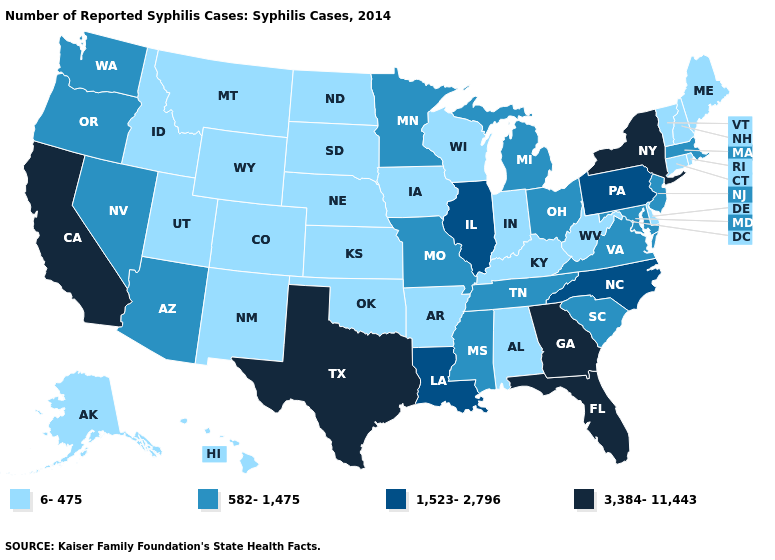Name the states that have a value in the range 1,523-2,796?
Answer briefly. Illinois, Louisiana, North Carolina, Pennsylvania. What is the highest value in states that border New Mexico?
Write a very short answer. 3,384-11,443. What is the value of Missouri?
Short answer required. 582-1,475. How many symbols are there in the legend?
Write a very short answer. 4. What is the value of Pennsylvania?
Short answer required. 1,523-2,796. Name the states that have a value in the range 1,523-2,796?
Short answer required. Illinois, Louisiana, North Carolina, Pennsylvania. Name the states that have a value in the range 6-475?
Short answer required. Alabama, Alaska, Arkansas, Colorado, Connecticut, Delaware, Hawaii, Idaho, Indiana, Iowa, Kansas, Kentucky, Maine, Montana, Nebraska, New Hampshire, New Mexico, North Dakota, Oklahoma, Rhode Island, South Dakota, Utah, Vermont, West Virginia, Wisconsin, Wyoming. What is the lowest value in the Northeast?
Answer briefly. 6-475. Does the first symbol in the legend represent the smallest category?
Be succinct. Yes. Is the legend a continuous bar?
Answer briefly. No. Among the states that border New Mexico , does Colorado have the highest value?
Concise answer only. No. Among the states that border Louisiana , which have the highest value?
Keep it brief. Texas. Does Arkansas have the highest value in the South?
Write a very short answer. No. Name the states that have a value in the range 1,523-2,796?
Answer briefly. Illinois, Louisiana, North Carolina, Pennsylvania. What is the highest value in the West ?
Answer briefly. 3,384-11,443. 